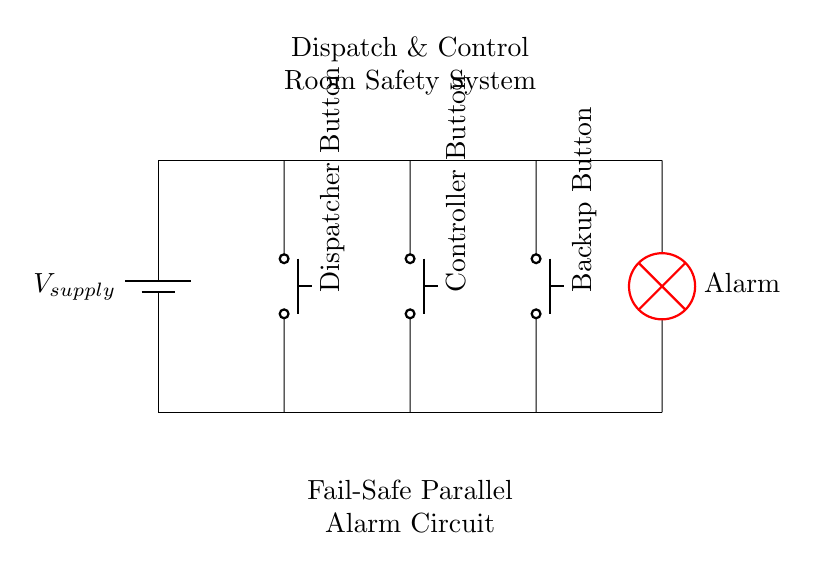What is the type of circuit shown? The circuit is a parallel circuit, as multiple components are connected across the same voltage source independently. Each of the buttons operates individually without affecting the others.
Answer: Parallel How many push buttons are present in the circuit? There are three push buttons illustrated in the circuit: Dispatcher Button, Controller Button, and Backup Button. Each button is arranged to control the alarm independently.
Answer: Three What is the function of the red lamp in the circuit? The red lamp represents the alarm system, which activates to indicate an alert or emergency situation when any of the push buttons are pressed. This function is crucial in a dispatch and control room for immediate notification.
Answer: Alarm What happens if one button fails? If one button fails, the other buttons can still activate the alarm due to the parallel configuration, ensuring that the alarm system remains functional regardless of individual component failure. This enhances reliability in emergencies.
Answer: Alarm still activates What is the role of the voltage supply in this circuit? The voltage supply provides the necessary electrical potential to activate the buttons and the alarm. It ensures that there is a continuous source of power available for the operation of the entire alarm system.
Answer: Power source How is redundancy achieved in this alarm system? Redundancy is achieved by connecting multiple push buttons in parallel. This allows any single button to trigger the alarm, ensuring the system remains operable even if one component fails. The design increases the reliability of the alarm system in critical situations.
Answer: Through parallel configuration 